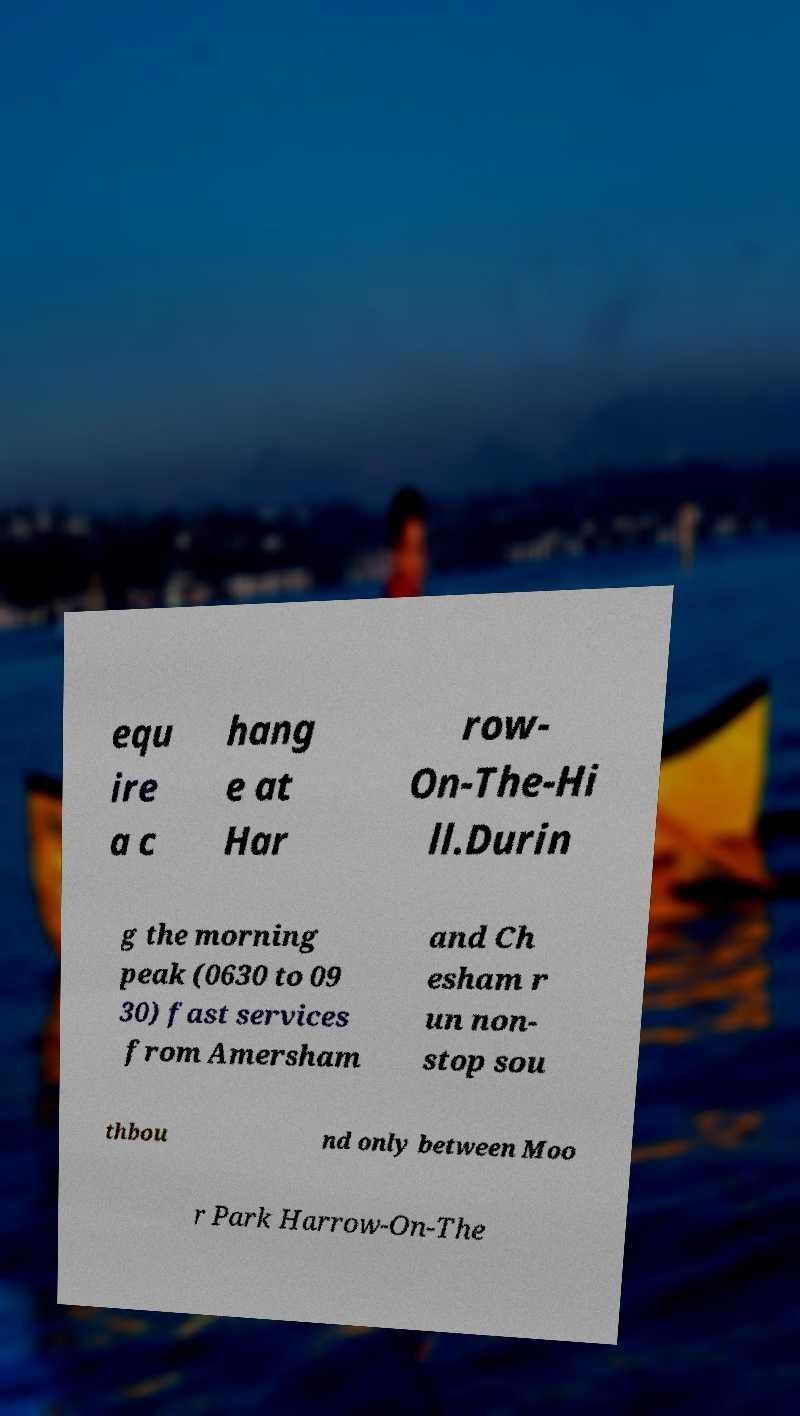Can you accurately transcribe the text from the provided image for me? equ ire a c hang e at Har row- On-The-Hi ll.Durin g the morning peak (0630 to 09 30) fast services from Amersham and Ch esham r un non- stop sou thbou nd only between Moo r Park Harrow-On-The 